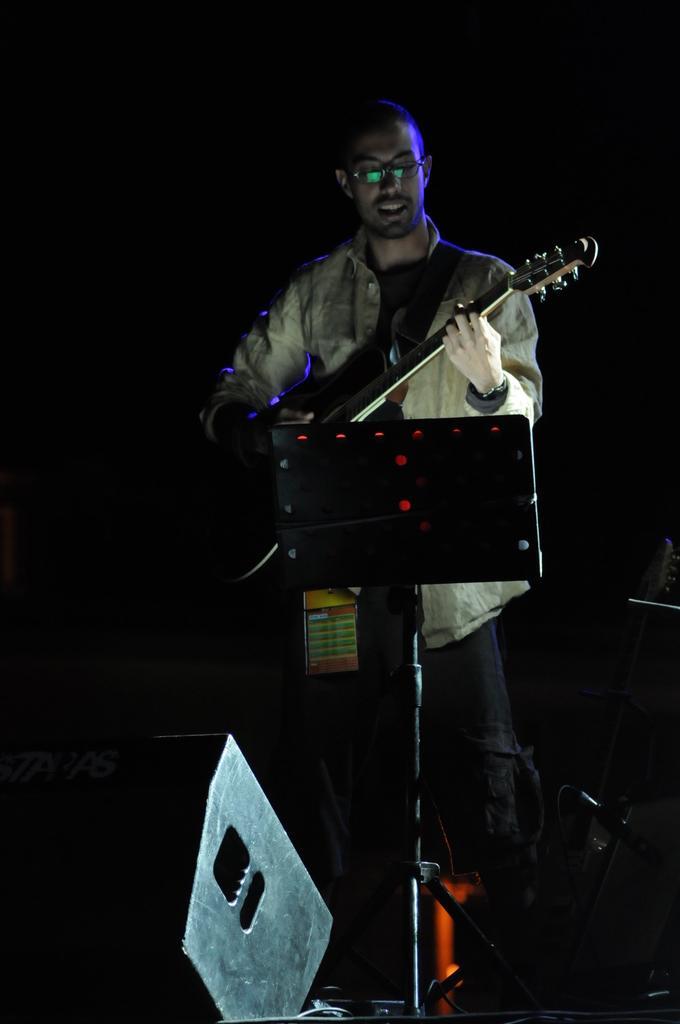Can you describe this image briefly? Background is dark. Here we can see one man , wearing spectacles standing in front of a podium and playing guitar. This is a device. 